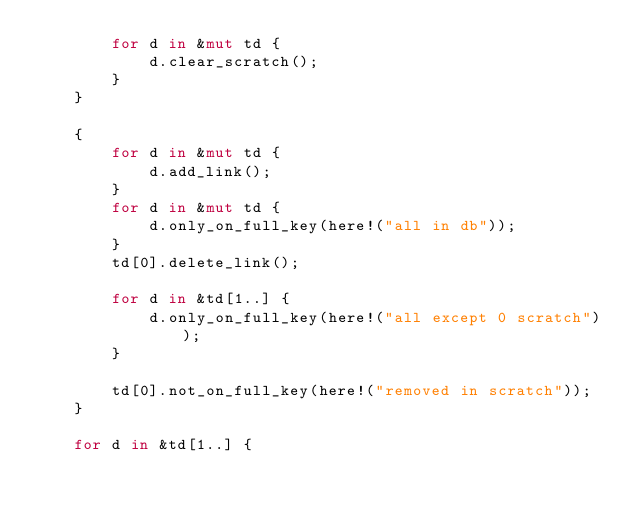Convert code to text. <code><loc_0><loc_0><loc_500><loc_500><_Rust_>        for d in &mut td {
            d.clear_scratch();
        }
    }

    {
        for d in &mut td {
            d.add_link();
        }
        for d in &mut td {
            d.only_on_full_key(here!("all in db"));
        }
        td[0].delete_link();

        for d in &td[1..] {
            d.only_on_full_key(here!("all except 0 scratch"));
        }

        td[0].not_on_full_key(here!("removed in scratch"));
    }

    for d in &td[1..] {</code> 